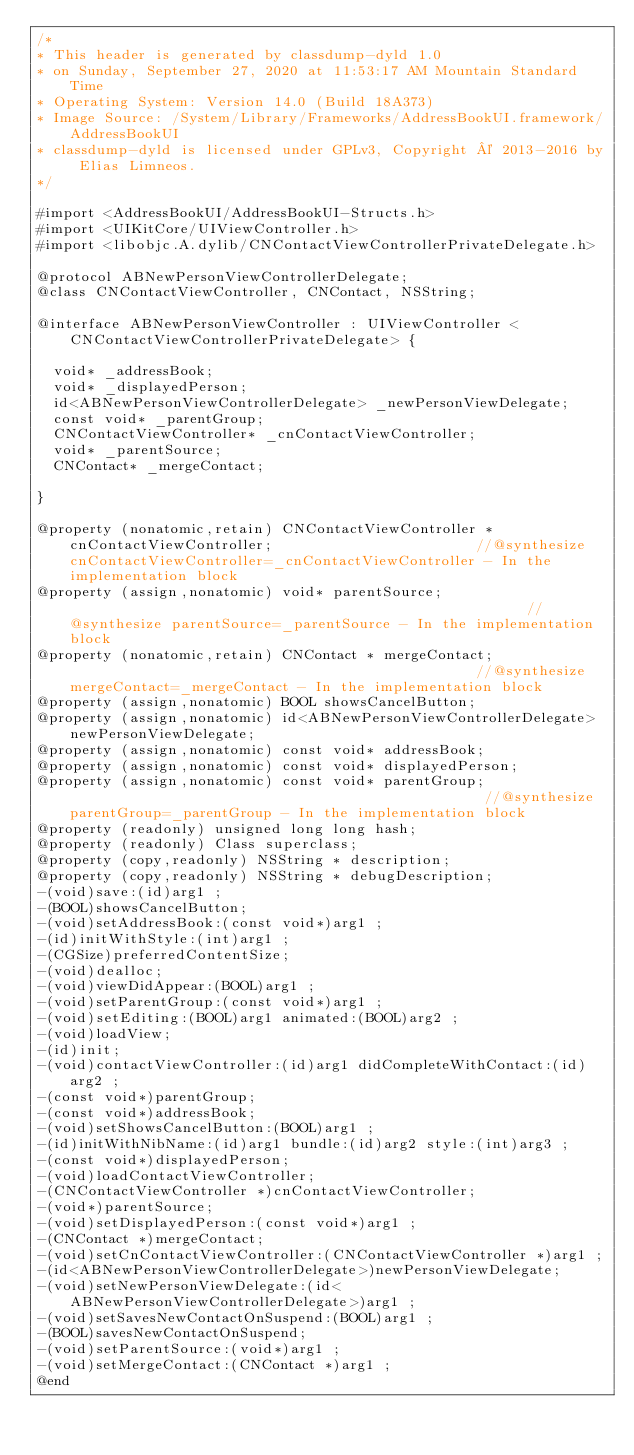Convert code to text. <code><loc_0><loc_0><loc_500><loc_500><_C_>/*
* This header is generated by classdump-dyld 1.0
* on Sunday, September 27, 2020 at 11:53:17 AM Mountain Standard Time
* Operating System: Version 14.0 (Build 18A373)
* Image Source: /System/Library/Frameworks/AddressBookUI.framework/AddressBookUI
* classdump-dyld is licensed under GPLv3, Copyright © 2013-2016 by Elias Limneos.
*/

#import <AddressBookUI/AddressBookUI-Structs.h>
#import <UIKitCore/UIViewController.h>
#import <libobjc.A.dylib/CNContactViewControllerPrivateDelegate.h>

@protocol ABNewPersonViewControllerDelegate;
@class CNContactViewController, CNContact, NSString;

@interface ABNewPersonViewController : UIViewController <CNContactViewControllerPrivateDelegate> {

	void* _addressBook;
	void* _displayedPerson;
	id<ABNewPersonViewControllerDelegate> _newPersonViewDelegate;
	const void* _parentGroup;
	CNContactViewController* _cnContactViewController;
	void* _parentSource;
	CNContact* _mergeContact;

}

@property (nonatomic,retain) CNContactViewController * cnContactViewController;                        //@synthesize cnContactViewController=_cnContactViewController - In the implementation block
@property (assign,nonatomic) void* parentSource;                                                       //@synthesize parentSource=_parentSource - In the implementation block
@property (nonatomic,retain) CNContact * mergeContact;                                                 //@synthesize mergeContact=_mergeContact - In the implementation block
@property (assign,nonatomic) BOOL showsCancelButton; 
@property (assign,nonatomic) id<ABNewPersonViewControllerDelegate> newPersonViewDelegate; 
@property (assign,nonatomic) const void* addressBook; 
@property (assign,nonatomic) const void* displayedPerson; 
@property (assign,nonatomic) const void* parentGroup;                                                  //@synthesize parentGroup=_parentGroup - In the implementation block
@property (readonly) unsigned long long hash; 
@property (readonly) Class superclass; 
@property (copy,readonly) NSString * description; 
@property (copy,readonly) NSString * debugDescription; 
-(void)save:(id)arg1 ;
-(BOOL)showsCancelButton;
-(void)setAddressBook:(const void*)arg1 ;
-(id)initWithStyle:(int)arg1 ;
-(CGSize)preferredContentSize;
-(void)dealloc;
-(void)viewDidAppear:(BOOL)arg1 ;
-(void)setParentGroup:(const void*)arg1 ;
-(void)setEditing:(BOOL)arg1 animated:(BOOL)arg2 ;
-(void)loadView;
-(id)init;
-(void)contactViewController:(id)arg1 didCompleteWithContact:(id)arg2 ;
-(const void*)parentGroup;
-(const void*)addressBook;
-(void)setShowsCancelButton:(BOOL)arg1 ;
-(id)initWithNibName:(id)arg1 bundle:(id)arg2 style:(int)arg3 ;
-(const void*)displayedPerson;
-(void)loadContactViewController;
-(CNContactViewController *)cnContactViewController;
-(void*)parentSource;
-(void)setDisplayedPerson:(const void*)arg1 ;
-(CNContact *)mergeContact;
-(void)setCnContactViewController:(CNContactViewController *)arg1 ;
-(id<ABNewPersonViewControllerDelegate>)newPersonViewDelegate;
-(void)setNewPersonViewDelegate:(id<ABNewPersonViewControllerDelegate>)arg1 ;
-(void)setSavesNewContactOnSuspend:(BOOL)arg1 ;
-(BOOL)savesNewContactOnSuspend;
-(void)setParentSource:(void*)arg1 ;
-(void)setMergeContact:(CNContact *)arg1 ;
@end

</code> 